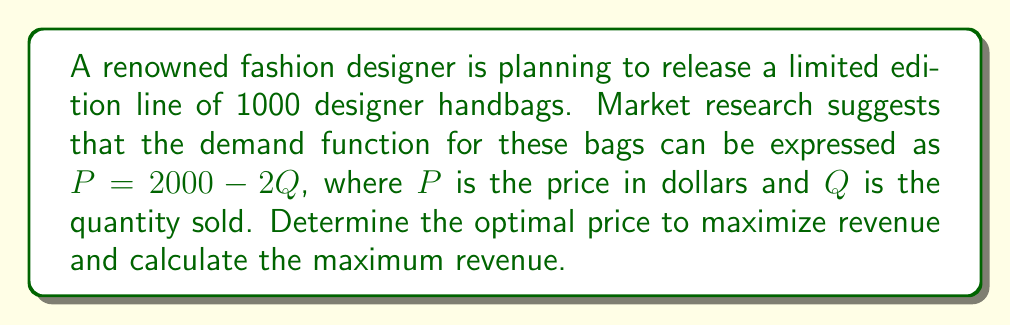Could you help me with this problem? To solve this problem, we'll follow these steps:

1) The revenue function $R(Q)$ is given by price times quantity:
   $$R(Q) = P \cdot Q = (2000 - 2Q) \cdot Q = 2000Q - 2Q^2$$

2) To find the maximum revenue, we need to find the value of $Q$ where the derivative of $R(Q)$ equals zero:
   $$\frac{dR}{dQ} = 2000 - 4Q$$

3) Set this equal to zero and solve for $Q$:
   $$2000 - 4Q = 0$$
   $$4Q = 2000$$
   $$Q = 500$$

4) To confirm this is a maximum, we can check that the second derivative is negative:
   $$\frac{d^2R}{dQ^2} = -4 < 0$$

5) Now that we know the optimal quantity is 500, we can find the optimal price:
   $$P = 2000 - 2Q = 2000 - 2(500) = 1000$$

6) The maximum revenue is:
   $$R(500) = 1000 \cdot 500 = 500,000$$

Therefore, the optimal price is $1000, and the maximum revenue is $500,000.
Answer: Optimal price: $1000; Maximum revenue: $500,000 